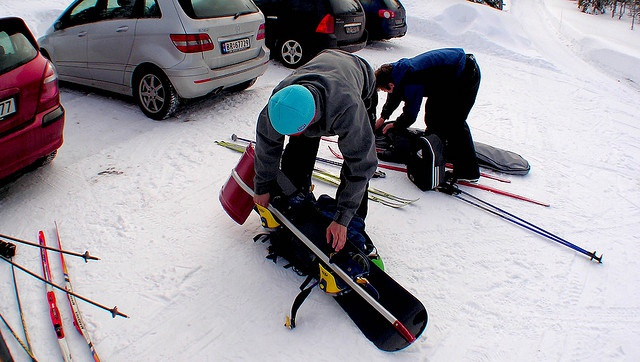Describe the objects in this image and their specific colors. I can see car in lightgray, gray, and black tones, people in lightgray, black, gray, and teal tones, snowboard in lightgray, black, darkgray, gray, and maroon tones, people in lightgray, black, navy, blue, and maroon tones, and car in lightgray, maroon, black, brown, and gray tones in this image. 